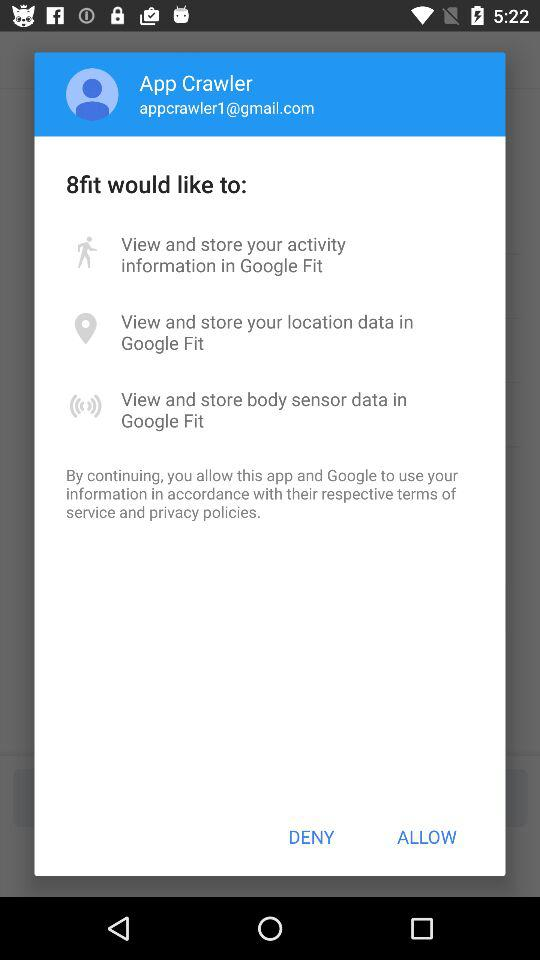How many body sensor data permissions are requested?
Answer the question using a single word or phrase. 1 